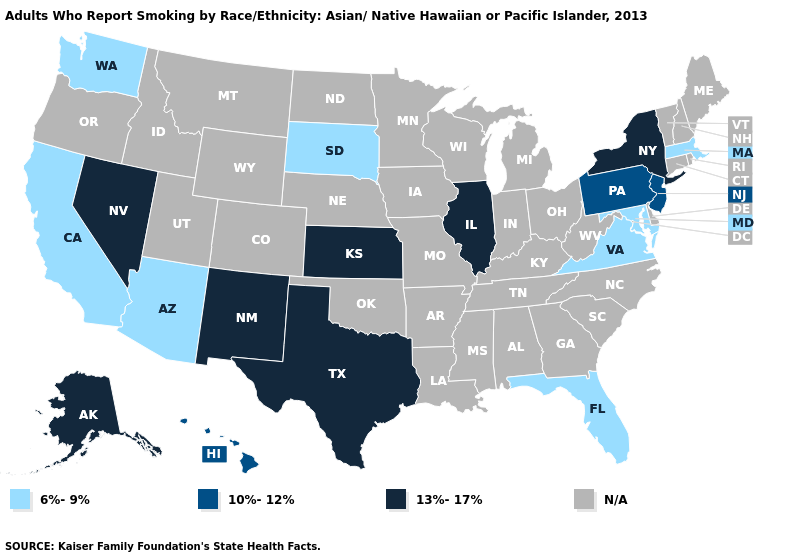Name the states that have a value in the range N/A?
Keep it brief. Alabama, Arkansas, Colorado, Connecticut, Delaware, Georgia, Idaho, Indiana, Iowa, Kentucky, Louisiana, Maine, Michigan, Minnesota, Mississippi, Missouri, Montana, Nebraska, New Hampshire, North Carolina, North Dakota, Ohio, Oklahoma, Oregon, Rhode Island, South Carolina, Tennessee, Utah, Vermont, West Virginia, Wisconsin, Wyoming. What is the lowest value in the USA?
Give a very brief answer. 6%-9%. Does the first symbol in the legend represent the smallest category?
Short answer required. Yes. Does Nevada have the lowest value in the West?
Be succinct. No. Does Maryland have the lowest value in the South?
Keep it brief. Yes. What is the lowest value in the USA?
Keep it brief. 6%-9%. Name the states that have a value in the range N/A?
Short answer required. Alabama, Arkansas, Colorado, Connecticut, Delaware, Georgia, Idaho, Indiana, Iowa, Kentucky, Louisiana, Maine, Michigan, Minnesota, Mississippi, Missouri, Montana, Nebraska, New Hampshire, North Carolina, North Dakota, Ohio, Oklahoma, Oregon, Rhode Island, South Carolina, Tennessee, Utah, Vermont, West Virginia, Wisconsin, Wyoming. Does the first symbol in the legend represent the smallest category?
Concise answer only. Yes. Which states have the highest value in the USA?
Keep it brief. Alaska, Illinois, Kansas, Nevada, New Mexico, New York, Texas. Is the legend a continuous bar?
Answer briefly. No. What is the lowest value in the South?
Write a very short answer. 6%-9%. What is the lowest value in the USA?
Be succinct. 6%-9%. Does New Jersey have the lowest value in the Northeast?
Write a very short answer. No. What is the highest value in the MidWest ?
Concise answer only. 13%-17%. 